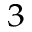Convert formula to latex. <formula><loc_0><loc_0><loc_500><loc_500>_ { 3 }</formula> 